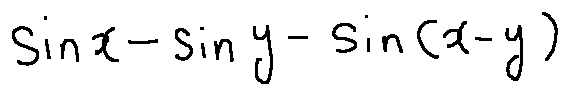<formula> <loc_0><loc_0><loc_500><loc_500>\sin x - \sin y - \sin ( x - y )</formula> 